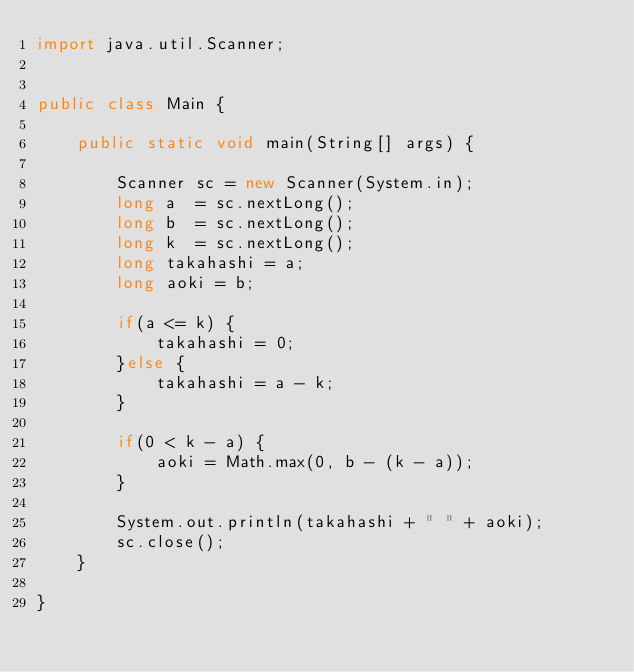Convert code to text. <code><loc_0><loc_0><loc_500><loc_500><_Java_>import java.util.Scanner;

 
public class Main {
 
	public static void main(String[] args) {
		
		Scanner sc = new Scanner(System.in);
		long a  = sc.nextLong();
		long b  = sc.nextLong();
		long k  = sc.nextLong();
		long takahashi = a;
		long aoki = b;
		
		if(a <= k) {
			takahashi = 0;
		}else {
			takahashi = a - k;
		}
		
		if(0 < k - a) {
			aoki = Math.max(0, b - (k - a));
		}
		
		System.out.println(takahashi + " " + aoki);
		sc.close();
	}
	
}</code> 